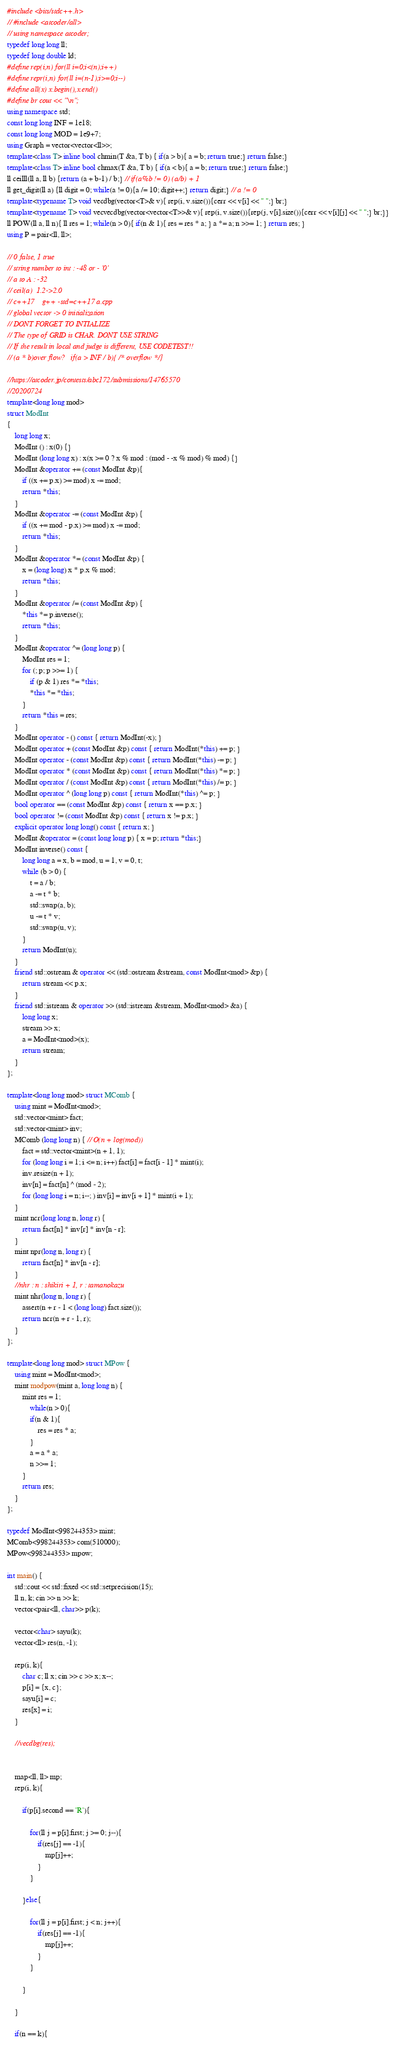<code> <loc_0><loc_0><loc_500><loc_500><_C++_>#include <bits/stdc++.h>
// #include <atcoder/all>
// using namespace atcoder;
typedef long long ll;
typedef long double ld;
#define rep(i,n) for(ll i=0;i<(n);i++)
#define repr(i,n) for(ll i=(n-1);i>=0;i--)
#define all(x) x.begin(),x.end()
#define br cout << "\n";
using namespace std;
const long long INF = 1e18;
const long long MOD = 1e9+7;
using Graph = vector<vector<ll>>;
template<class T> inline bool chmin(T &a, T b) { if(a > b){ a = b; return true;} return false;}
template<class T> inline bool chmax(T &a, T b) { if(a < b){ a = b; return true;} return false;}
ll ceilll(ll a, ll b) {return (a + b-1) / b;} // if(a%b != 0) (a/b) + 1
ll get_digit(ll a) {ll digit = 0; while(a != 0){a /= 10; digit++;} return digit;} // a != 0
template<typename T> void vecdbg(vector<T>& v){ rep(i, v.size()){cerr << v[i] << " ";} br;}
template<typename T> void vecvecdbg(vector<vector<T>>& v){ rep(i, v.size()){rep(j, v[i].size()){cerr << v[i][j] << " ";} br;}}
ll POW(ll a, ll n){ ll res = 1; while(n > 0){ if(n & 1){ res = res * a; } a *= a; n >>= 1; } return res; }
using P = pair<ll, ll>;

// 0 false, 1 true 
// string number to int : -48 or - '0'
// a to A : -32
// ceil(a)  1.2->2.0
// c++17	g++ -std=c++17 a.cpp
// global vector -> 0 initialization
// DONT FORGET TO INTIALIZE
// The type of GRID is CHAR. DONT USE STRING
// If the result in local and judge is different, USE CODETEST!!
// (a * b)over flow?   if(a > INF / b){ /* overflow */}

//https://atcoder.jp/contests/abc172/submissions/14765570
//20200724
template<long long mod>
struct ModInt
{
    long long x;
    ModInt () : x(0) {}
    ModInt (long long x) : x(x >= 0 ? x % mod : (mod - -x % mod) % mod) {}
    ModInt &operator += (const ModInt &p){
        if ((x += p.x) >= mod) x -= mod;
        return *this;
    }
    ModInt &operator -= (const ModInt &p) {
        if ((x += mod - p.x) >= mod) x -= mod;
        return *this;
    }
    ModInt &operator *= (const ModInt &p) {
        x = (long long) x * p.x % mod;
        return *this;
    }
    ModInt &operator /= (const ModInt &p) {
        *this *= p.inverse();
        return *this;
    }
    ModInt &operator ^= (long long p) {
        ModInt res = 1;
        for (; p; p >>= 1) {
            if (p & 1) res *= *this;
            *this *= *this;
        }
        return *this = res;
    }
    ModInt operator - () const { return ModInt(-x); }
    ModInt operator + (const ModInt &p) const { return ModInt(*this) += p; }
    ModInt operator - (const ModInt &p) const { return ModInt(*this) -= p; }
    ModInt operator * (const ModInt &p) const { return ModInt(*this) *= p; }
    ModInt operator / (const ModInt &p) const { return ModInt(*this) /= p; }
    ModInt operator ^ (long long p) const { return ModInt(*this) ^= p; }
    bool operator == (const ModInt &p) const { return x == p.x; }
    bool operator != (const ModInt &p) const { return x != p.x; }
    explicit operator long long() const { return x; }
    ModInt &operator = (const long long p) { x = p; return *this;}
    ModInt inverse() const {
        long long a = x, b = mod, u = 1, v = 0, t;
        while (b > 0) {
            t = a / b;
            a -= t * b;
            std::swap(a, b);
            u -= t * v;
            std::swap(u, v);
        }
        return ModInt(u);
    }
    friend std::ostream & operator << (std::ostream &stream, const ModInt<mod> &p) {
        return stream << p.x;
    }
    friend std::istream & operator >> (std::istream &stream, ModInt<mod> &a) {
        long long x;
        stream >> x;
        a = ModInt<mod>(x);
        return stream;
    }
};

template<long long mod> struct MComb {
    using mint = ModInt<mod>;
    std::vector<mint> fact;
    std::vector<mint> inv;
    MComb (long long n) { // O(n + log(mod))
        fact = std::vector<mint>(n + 1, 1);
        for (long long i = 1; i <= n; i++) fact[i] = fact[i - 1] * mint(i);
        inv.resize(n + 1);
        inv[n] = fact[n] ^ (mod - 2);
        for (long long i = n; i--; ) inv[i] = inv[i + 1] * mint(i + 1);
    }
    mint ncr(long long n, long r) {
        return fact[n] * inv[r] * inv[n - r];
    }
    mint npr(long n, long r) {
        return fact[n] * inv[n - r];
    }
    //nhr : n : shikiri + 1, r : tamanokazu
    mint nhr(long n, long r) {
        assert(n + r - 1 < (long long) fact.size());
        return ncr(n + r - 1, r);
    }
};

template<long long mod> struct MPow {
    using mint = ModInt<mod>;
    mint modpow(mint a, long long n) {
        mint res = 1;
            while(n > 0){
            if(n & 1){
                res = res * a;
            }
            a = a * a;
            n >>= 1;
        }
        return res;
    }
};

typedef ModInt<998244353> mint;
MComb<998244353> com(510000);
MPow<998244353> mpow;

int main() {
    std::cout << std::fixed << std::setprecision(15);
    ll n, k; cin >> n >> k;
    vector<pair<ll, char>> p(k);

    vector<char> sayu(k);
    vector<ll> res(n, -1);

    rep(i, k){
        char c; ll x; cin >> c >> x; x--;
        p[i] = {x, c};
        sayu[i] = c;
        res[x] = i;
    }

    //vecdbg(res);


    map<ll, ll> mp;
    rep(i, k){

        if(p[i].second == 'R'){

            for(ll j = p[i].first; j >= 0; j--){
                if(res[j] == -1){
                    mp[j]++;
                }
            }

        }else{

            for(ll j = p[i].first; j < n; j++){
                if(res[j] == -1){
                    mp[j]++;
                }
            }

        }

    }

    if(n == k){</code> 